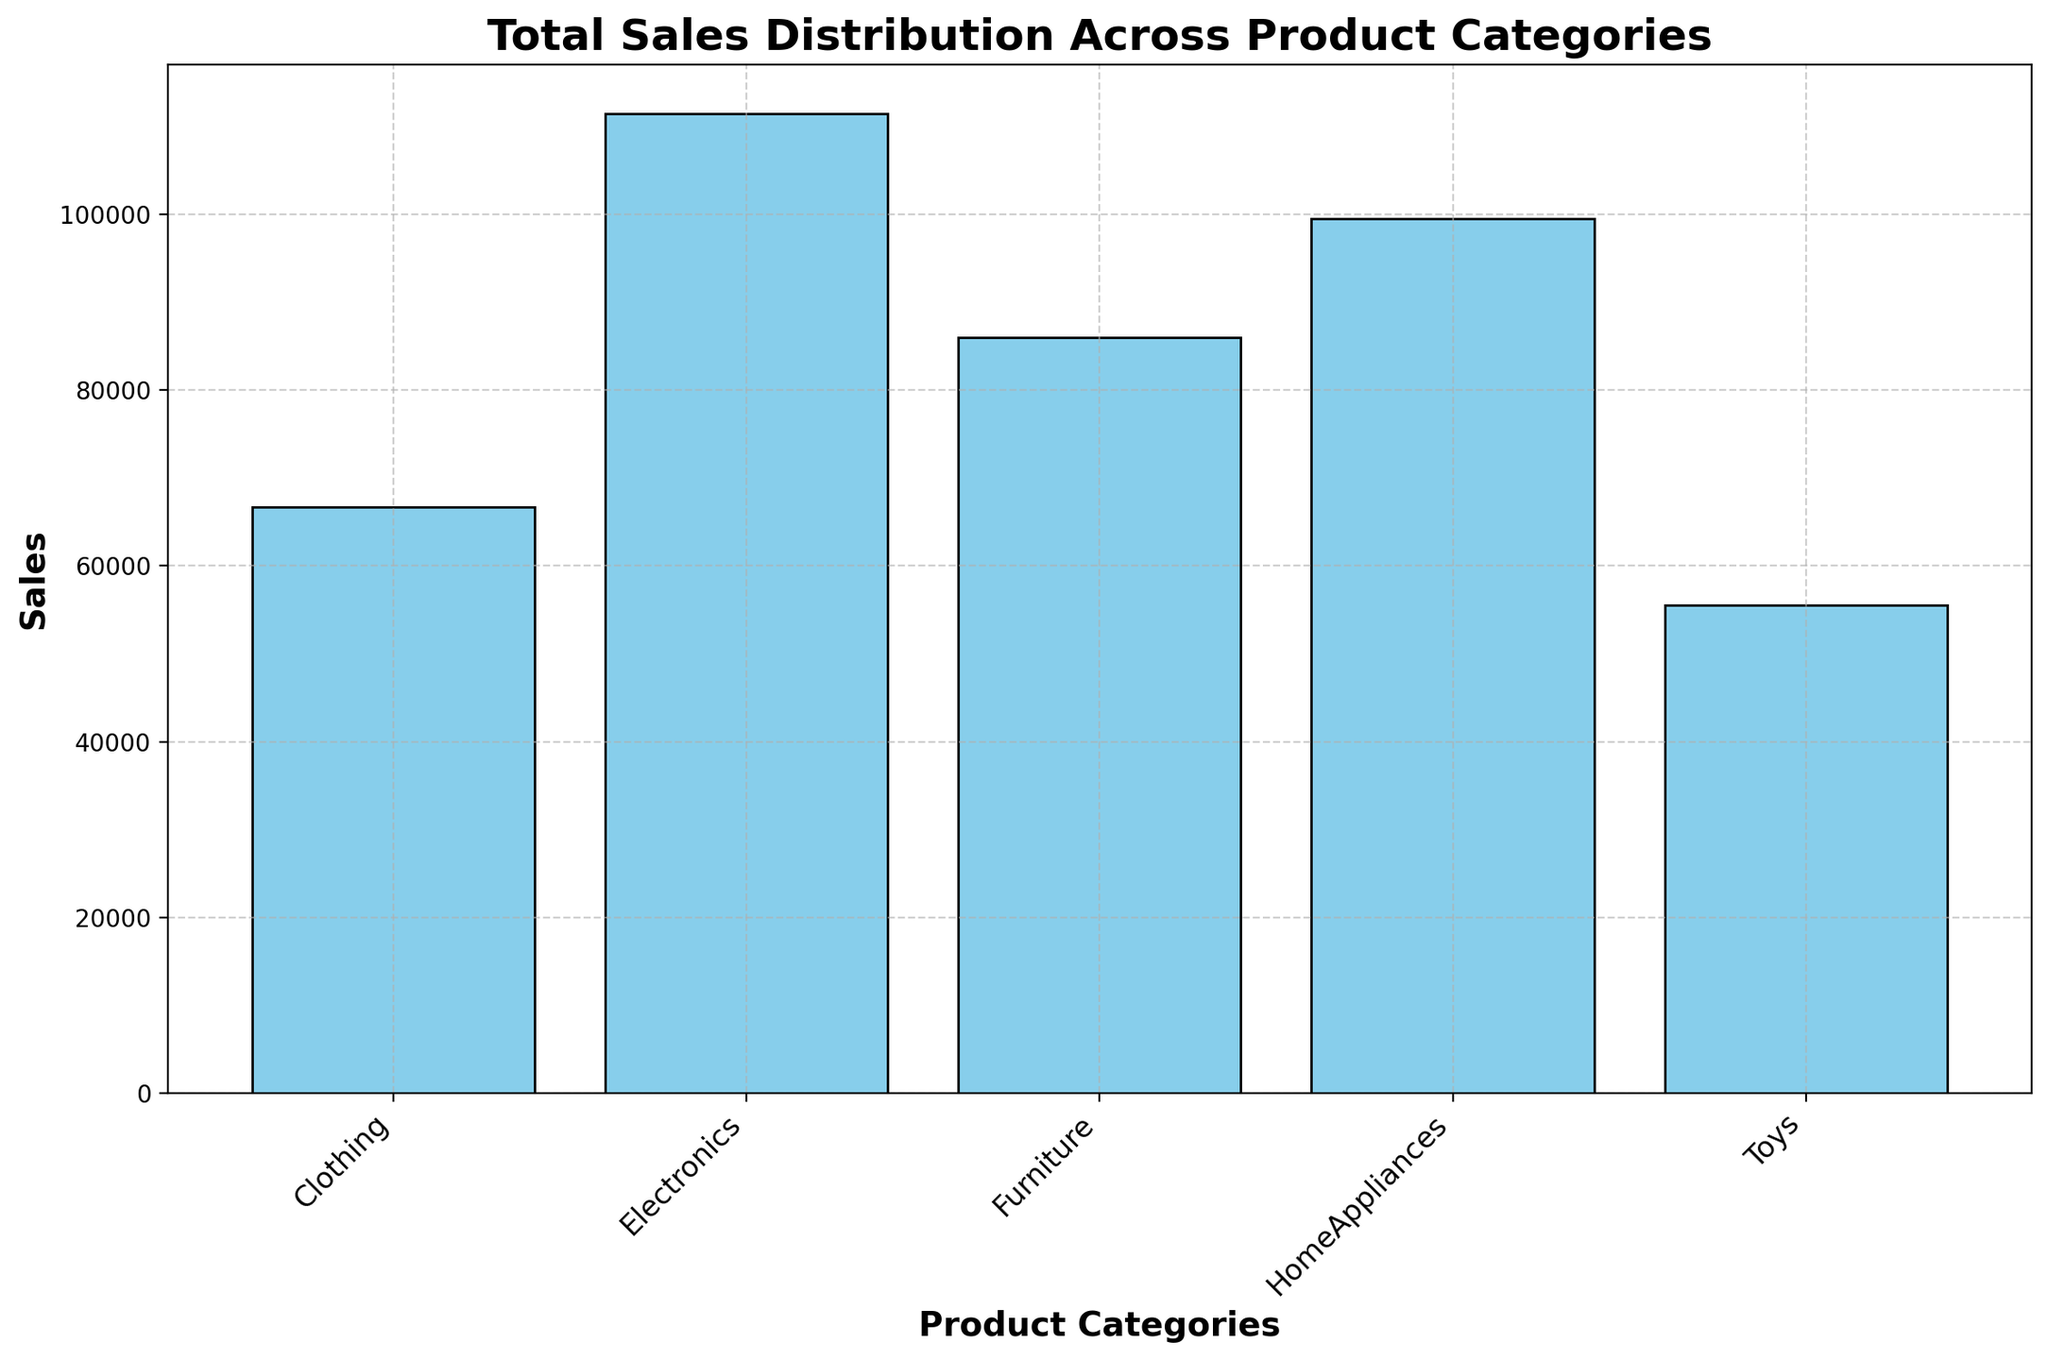Which product category has the highest total sales? By observing the height of the bars in the histogram, the bar representing the Home Appliances category is the tallest, indicating the highest total sales.
Answer: Home Appliances Which product category has the lowest total sales? By examining the height of the bars, the bar representing the Toys category is the shortest, indicating the lowest total sales.
Answer: Toys What's the total sales of Clothing compared to Furniture? By checking the height of the bars for Clothing and Furniture, Clothing has lower total sales than Furniture.
Answer: Lower Rank the product categories from highest to lowest in terms of total sales. By observing the heights of the bars and arranging them from tallest to shortest, we get: Home Appliances, Furniture, Electronics, Clothing, Toys.
Answer: Home Appliances, Furniture, Electronics, Clothing, Toys What is the sum of total sales for Electronics and Clothing categories? To find this, identify the heights of the bars for Electronics and Clothing, and sum their total sales values: Electronics (65500) + Clothing (44400) = 109900.
Answer: 109900 What's the total sales difference between Home Appliances and Toys? By noting the heights and calculating: Home Appliances (72000) - Toys (39000) = 33000.
Answer: 33000 Which product categories have total sales greater than 60,000? From the histogram, Home Appliances, Electronics, and Furniture have bars corresponding to total sales values greater than 60,000.
Answer: Home Appliances, Electronics, Furniture Compare the total sales of the second highest and second lowest product categories. By identifying the relevant bars: Furniture (51000) vs. Clothing (44400). The second highest is Furniture and the second lowest is Clothing.
Answer: Furniture: 51000, Clothing: 44400 Is there a noticeable difference between the total sales of Home Appliances and Electronics? By comparing the heights of the respective bars, Home Appliances has slightly higher total sales than Electronics.
Answer: Yes, Home Appliances is higher What's the average total sales across all product categories? Summing up total sales of all categories (72000 + 65500 + 51000 + 44400 + 39000) and dividing by the number of categories (5): (271900 / 5) = 54380.
Answer: 54380 